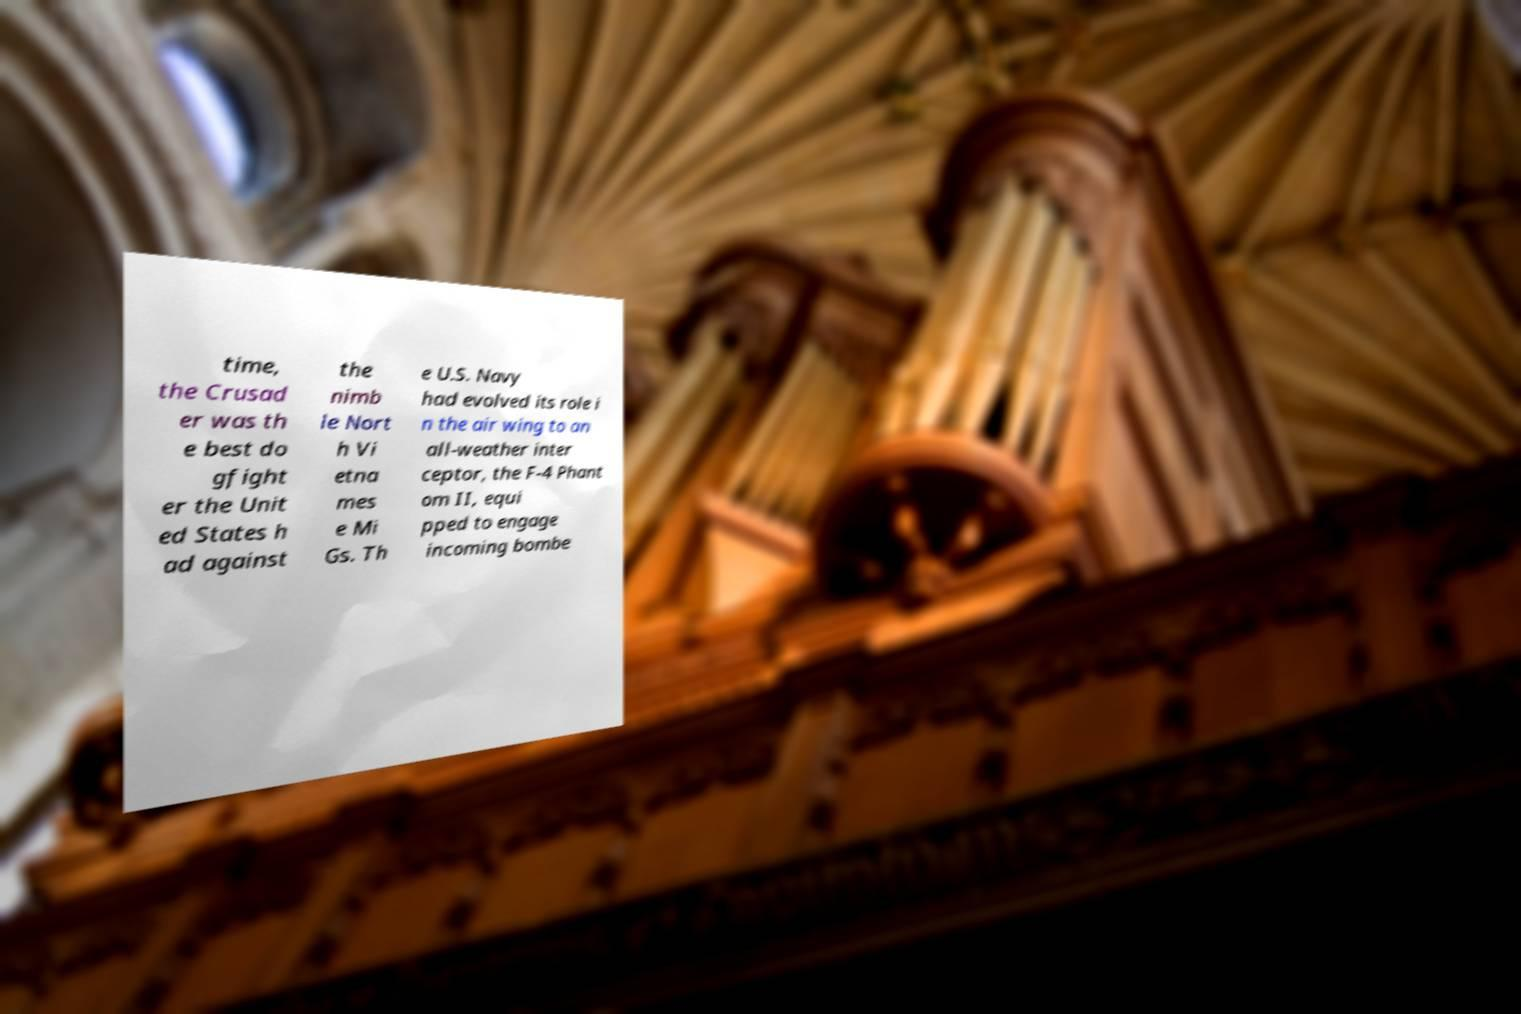Please read and relay the text visible in this image. What does it say? time, the Crusad er was th e best do gfight er the Unit ed States h ad against the nimb le Nort h Vi etna mes e Mi Gs. Th e U.S. Navy had evolved its role i n the air wing to an all-weather inter ceptor, the F-4 Phant om II, equi pped to engage incoming bombe 